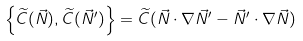Convert formula to latex. <formula><loc_0><loc_0><loc_500><loc_500>\left \{ \widetilde { C } ( \vec { N } ) , \widetilde { C } ( \vec { N } ^ { \prime } ) \right \} = \widetilde { C } ( \vec { N } \cdot \nabla \vec { N } ^ { \prime } - \vec { N } ^ { \prime } \cdot \nabla \vec { N } )</formula> 